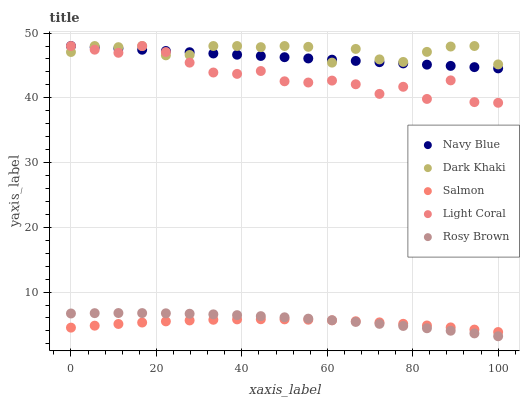Does Salmon have the minimum area under the curve?
Answer yes or no. Yes. Does Dark Khaki have the maximum area under the curve?
Answer yes or no. Yes. Does Navy Blue have the minimum area under the curve?
Answer yes or no. No. Does Navy Blue have the maximum area under the curve?
Answer yes or no. No. Is Navy Blue the smoothest?
Answer yes or no. Yes. Is Light Coral the roughest?
Answer yes or no. Yes. Is Rosy Brown the smoothest?
Answer yes or no. No. Is Rosy Brown the roughest?
Answer yes or no. No. Does Rosy Brown have the lowest value?
Answer yes or no. Yes. Does Navy Blue have the lowest value?
Answer yes or no. No. Does Light Coral have the highest value?
Answer yes or no. Yes. Does Rosy Brown have the highest value?
Answer yes or no. No. Is Rosy Brown less than Light Coral?
Answer yes or no. Yes. Is Light Coral greater than Salmon?
Answer yes or no. Yes. Does Navy Blue intersect Light Coral?
Answer yes or no. Yes. Is Navy Blue less than Light Coral?
Answer yes or no. No. Is Navy Blue greater than Light Coral?
Answer yes or no. No. Does Rosy Brown intersect Light Coral?
Answer yes or no. No. 